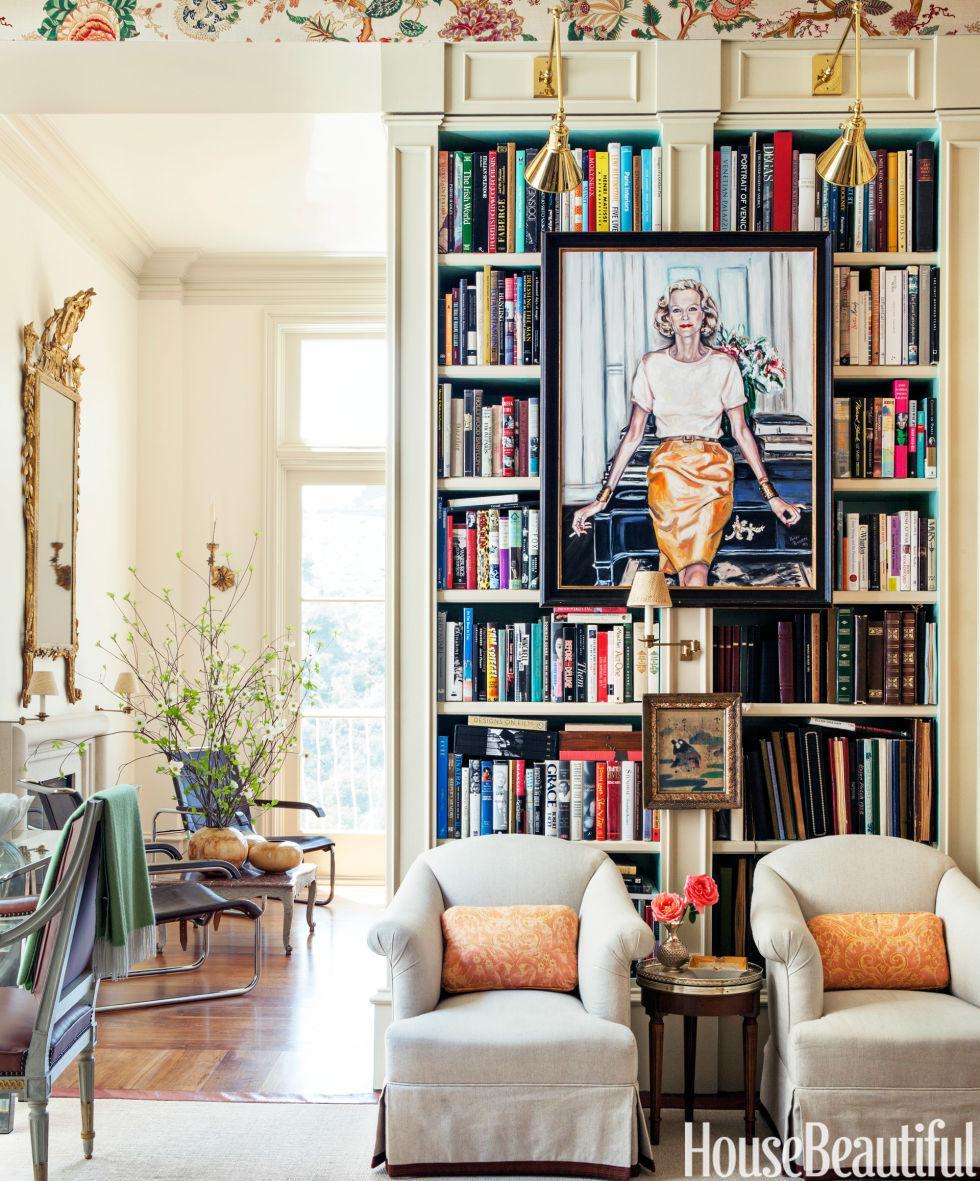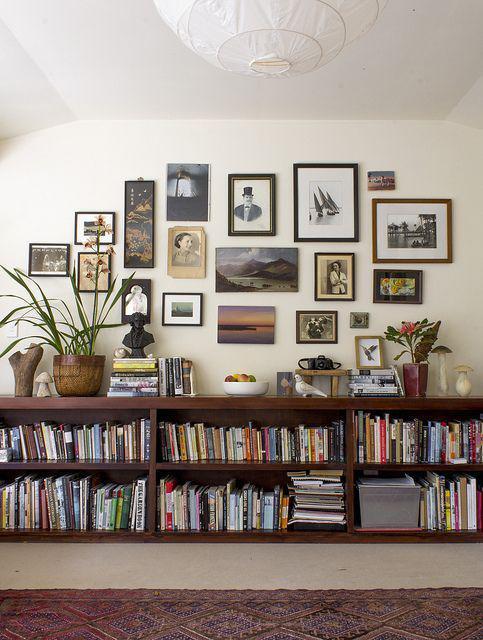The first image is the image on the left, the second image is the image on the right. Considering the images on both sides, is "In one image, a wall bookshelf unit with at least six shelves has at least one piece of framed artwork mounted to the front of the shelf, obscuring some of the contents." valid? Answer yes or no. Yes. The first image is the image on the left, the second image is the image on the right. Evaluate the accuracy of this statement regarding the images: "The right image shows a ladder leaned up against the front of a stocked bookshelf.". Is it true? Answer yes or no. No. 